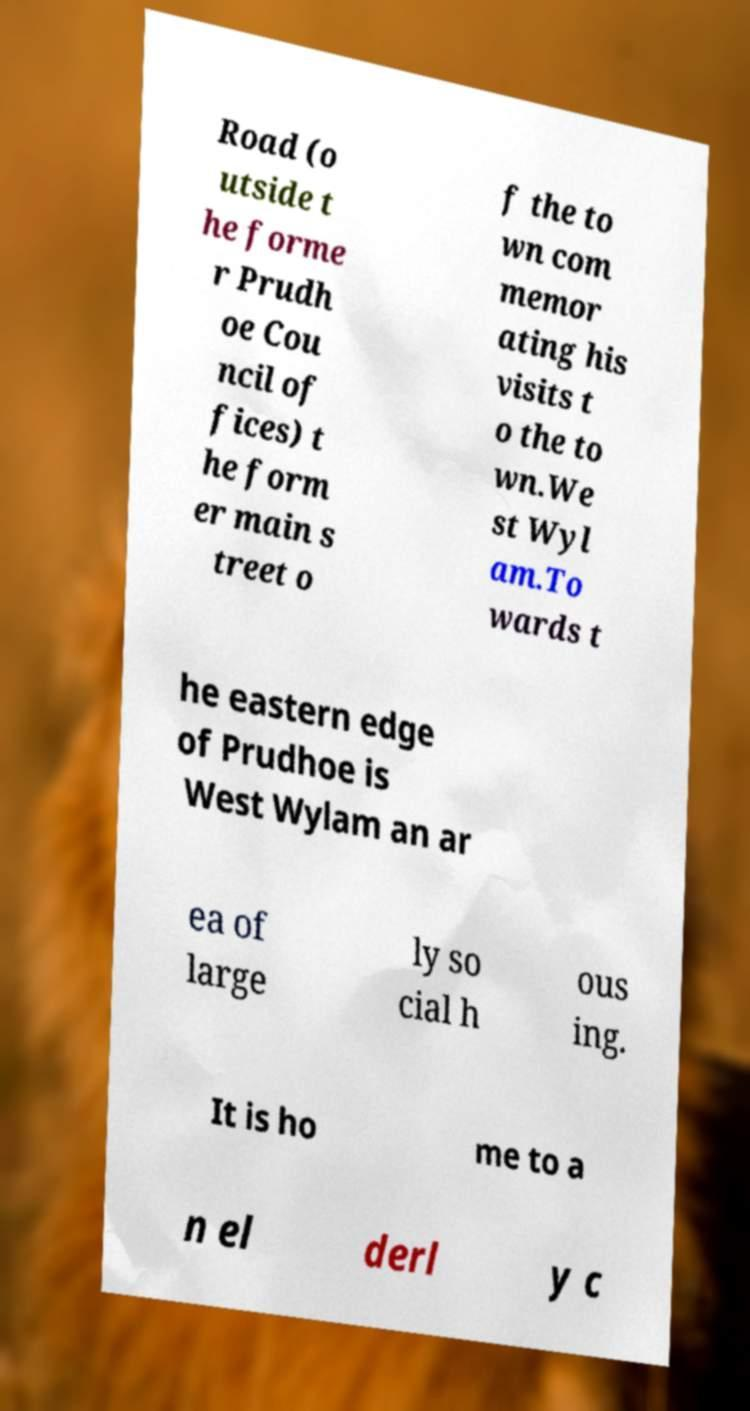For documentation purposes, I need the text within this image transcribed. Could you provide that? Road (o utside t he forme r Prudh oe Cou ncil of fices) t he form er main s treet o f the to wn com memor ating his visits t o the to wn.We st Wyl am.To wards t he eastern edge of Prudhoe is West Wylam an ar ea of large ly so cial h ous ing. It is ho me to a n el derl y c 